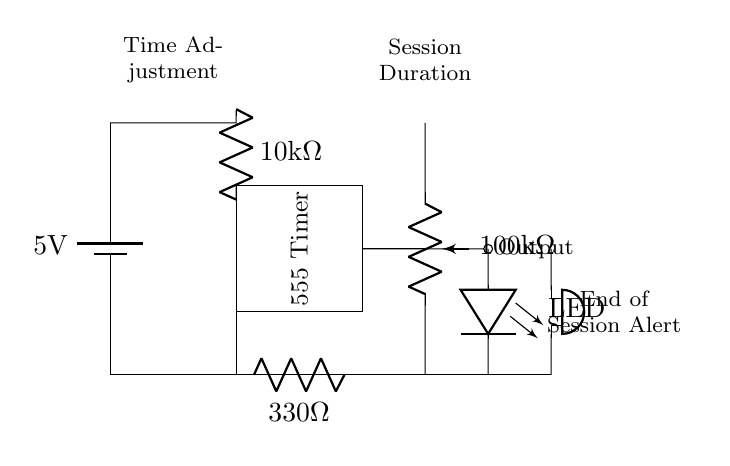What is the voltage supplied to the circuit? The voltage supplied to the circuit is indicated by the battery symbol, which shows a value of 5 volts.
Answer: 5 volts What component is used to adjust the session duration? The component used to adjust the session duration is labeled as a potentiometer with a resistance value of 100 kΩ, which allows for variable resistance and thus determines the timing.
Answer: Potentiometer What type of timer is shown in this circuit? The circuit diagram features a 555 timer IC, which is a commonly used timer for timing applications, indicating that this is the main component controlling timing operations.
Answer: 555 Timer What alerts the end of the meditation session? The circuit indicates that there is a buzzer connected to the output of the timer, which will sound when the session is completed, thus providing an alert.
Answer: Buzzer How is the LED used in this circuit? The LED functions as an indicator light, connected to the output of the timer; it lights up to show when the timer is active, signaling the ongoing meditation session.
Answer: Indicator What resistance value is used to limit the LED current? The circuit includes a resistor labeled as 330 ohms, which is connected in series with the LED to limit the current passing through it and protect the LED from damage.
Answer: 330 ohms How can you change the duration for kids' activities? The duration can be changed by adjusting the potentiometer, which alters the resistance and consequently modifies the time period for the 555 timer output.
Answer: Adjusting the potentiometer 